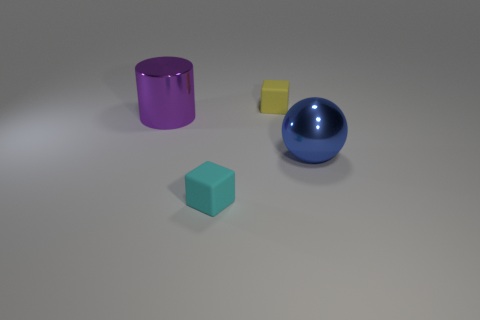Add 3 large blue balls. How many objects exist? 7 Subtract all balls. How many objects are left? 3 Add 1 metal spheres. How many metal spheres are left? 2 Add 2 tiny blue spheres. How many tiny blue spheres exist? 2 Subtract 0 red cylinders. How many objects are left? 4 Subtract all tiny yellow matte blocks. Subtract all cyan balls. How many objects are left? 3 